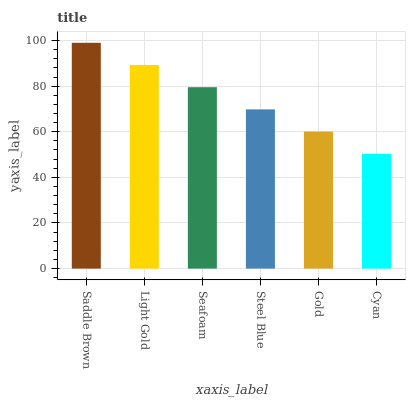Is Cyan the minimum?
Answer yes or no. Yes. Is Saddle Brown the maximum?
Answer yes or no. Yes. Is Light Gold the minimum?
Answer yes or no. No. Is Light Gold the maximum?
Answer yes or no. No. Is Saddle Brown greater than Light Gold?
Answer yes or no. Yes. Is Light Gold less than Saddle Brown?
Answer yes or no. Yes. Is Light Gold greater than Saddle Brown?
Answer yes or no. No. Is Saddle Brown less than Light Gold?
Answer yes or no. No. Is Seafoam the high median?
Answer yes or no. Yes. Is Steel Blue the low median?
Answer yes or no. Yes. Is Gold the high median?
Answer yes or no. No. Is Cyan the low median?
Answer yes or no. No. 